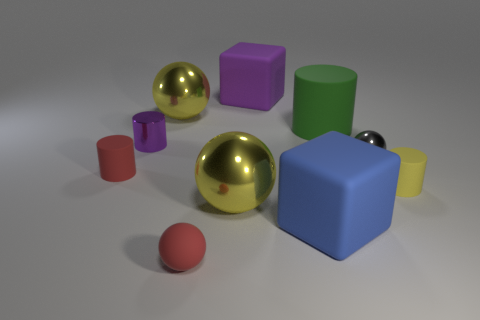Describe the textures of the different objects present in the image. The image showcases objects with a variety of textures. The red rubber cylinder has a matte finish, the cylinders and cubes appear to have a smooth, solid-colored surface, while the golden and silver spheres have a reflective, metallic texture. 